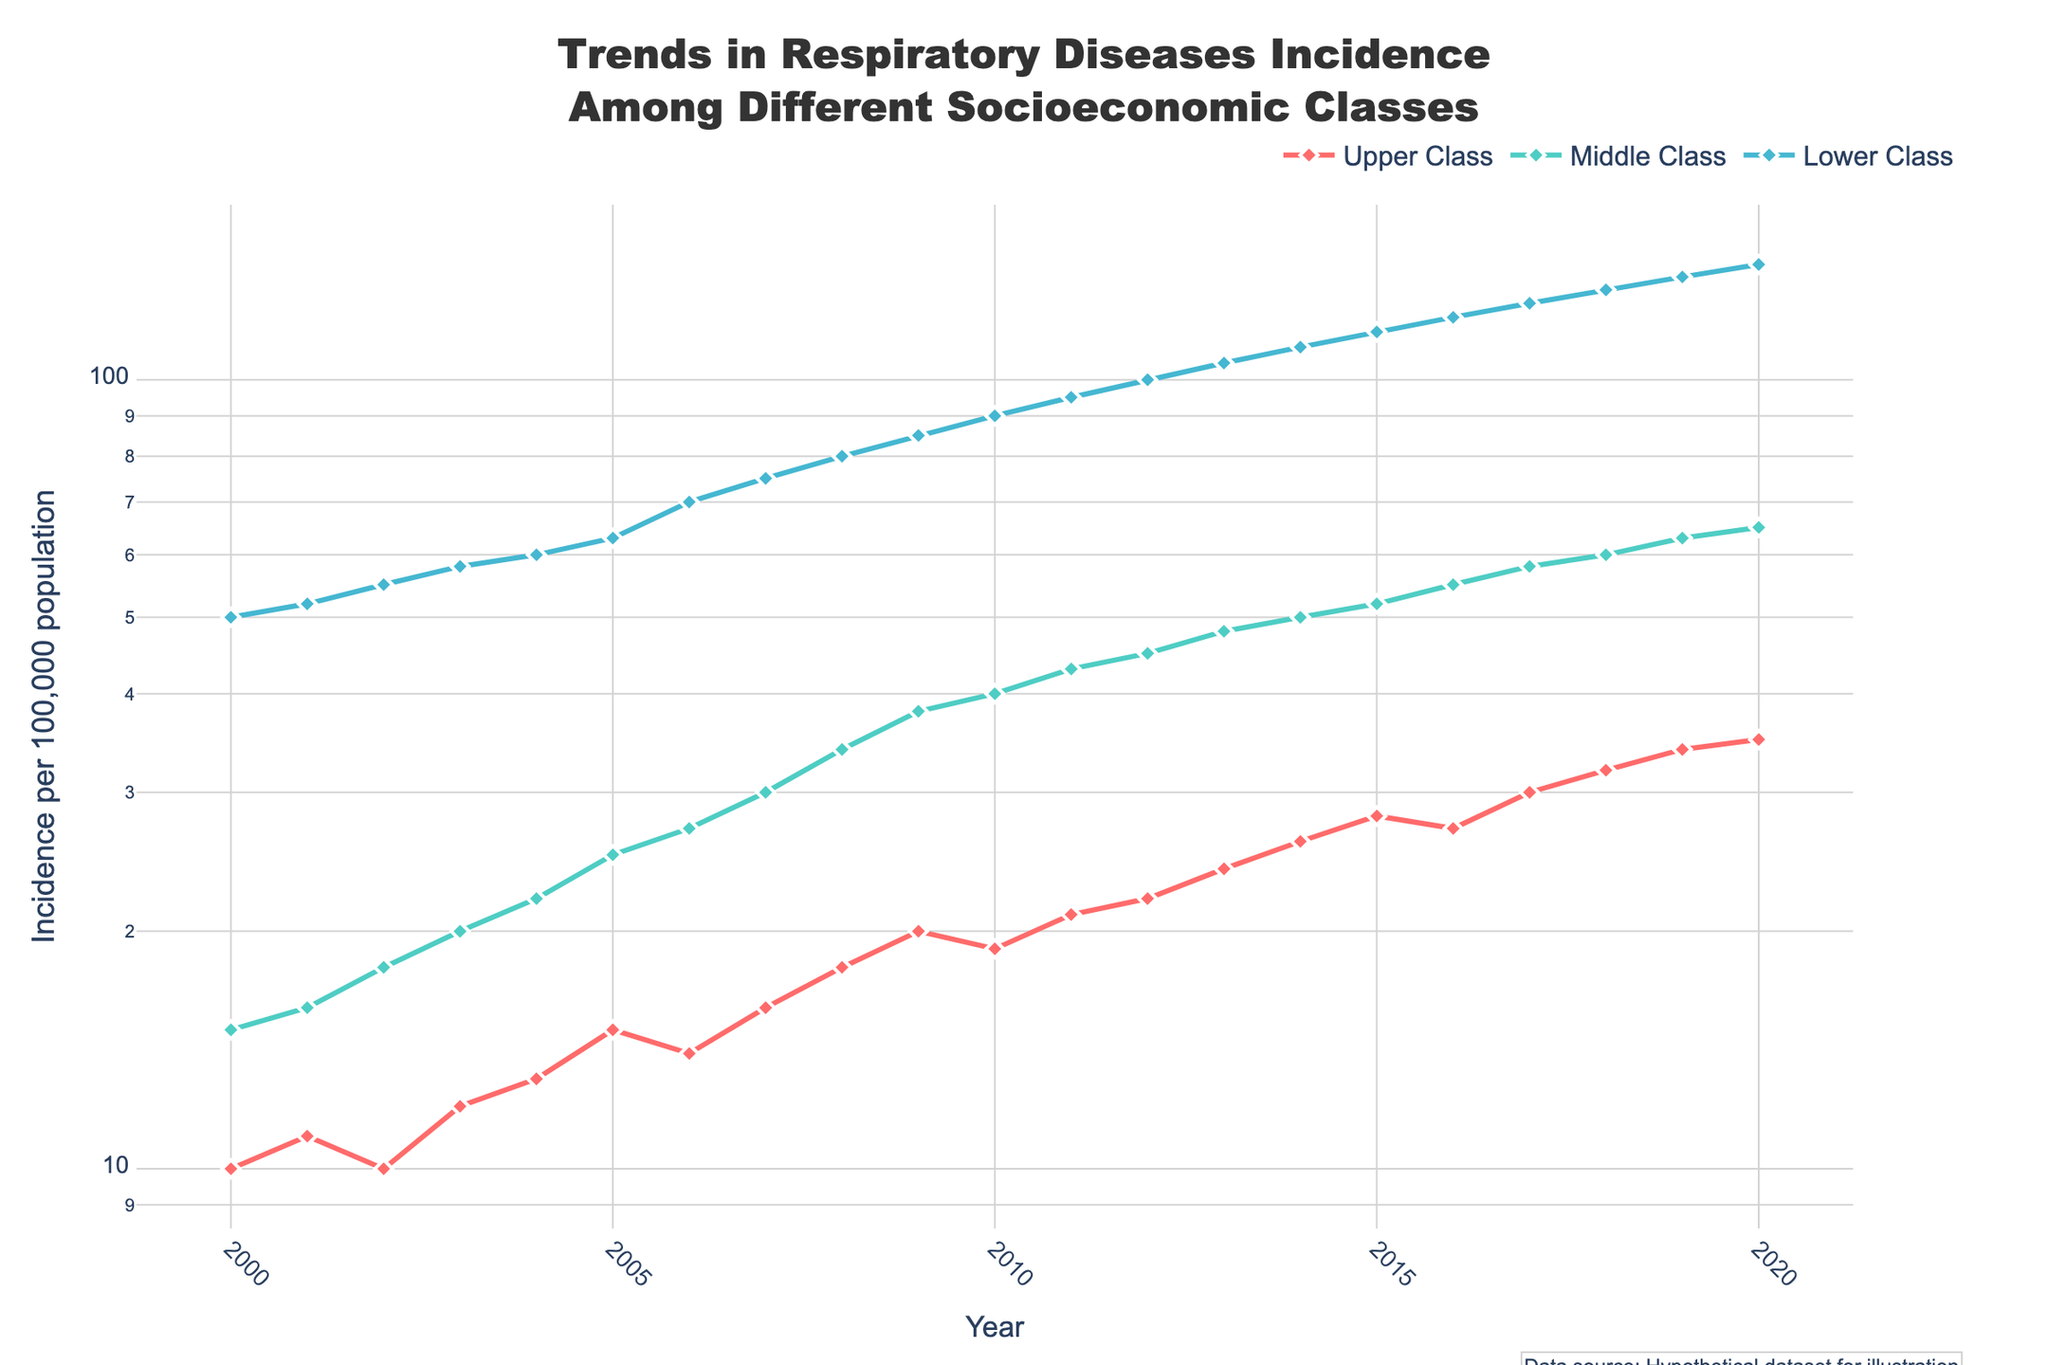What is the title of the figure? The title is usually displayed at the top center of the figure. It provides an overview of what the plot is about. The title reads, "Trends in Respiratory Diseases Incidence Among Different Socioeconomic Classes."
Answer: Trends in Respiratory Diseases Incidence Among Different Socioeconomic Classes Which class had the lowest incidence of respiratory diseases in 2000? By looking at the data points on the leftmost part of the plot corresponding to the year 2000, we can compare the incidence among the three classes. The "Upper Class" had the lowest incidence.
Answer: Upper Class How did the incidence in the Lower Class change from 2000 to 2020? We locate the data points for the Lower Class at the years 2000 and 2020. In 2000, the incidence was 50, and in 2020, it was 140. Subtracting these gives an increase of 90.
Answer: Increased by 90 Which class shows the steepest increase in incidence over the years? Observing the slope of the lines representing each class, the "Lower Class" line has the steepest upward trend. This indicates a faster rate of increase compared to the other classes.
Answer: Lower Class What is the average incidence of respiratory diseases in the Middle Class from 2010 to 2020? We take the data points for the Middle Class from 2010 to 2020: (40, 43, 45, 48, 50, 52, 55, 58, 60, 63, 65). Summing them gives a total of 529, and there are 11 years, so the average is 529/11.
Answer: 48 By how much did the incidence in the Upper Class increase between 2011 and 2018? We check the Upper Class data points in 2011 and 2018, which are 21 and 32, respectively. The increase is 32 - 21 = 11.
Answer: 11 Which socioeconomic class had the highest incidence in 2020? Inspecting the data points at the far right of the plot for 2020, the "Lower Class" has the highest incidence.
Answer: Lower Class How did the incidence in the Middle Class compare to the Lower Class in 2012? In 2012, the incidence for the Middle Class was 45, and for the Lower Class, it was 100. Subtracting these, 100 - 45 = 55, so the difference is 55.
Answer: 55 Is there a year where the incidence for the Upper Class was higher than Middle Class? We'll review the yearly data points for both classes. In each year, the Upper Class incidence is consistently lower than the Middle Class incidence.
Answer: No What kind of scale is used on the y-axis? The y-axis shows incidence values that span several orders of magnitude. Hence, the y-axis uses a logarithmic scale to better illustrate the data.
Answer: Logarithmic scale 